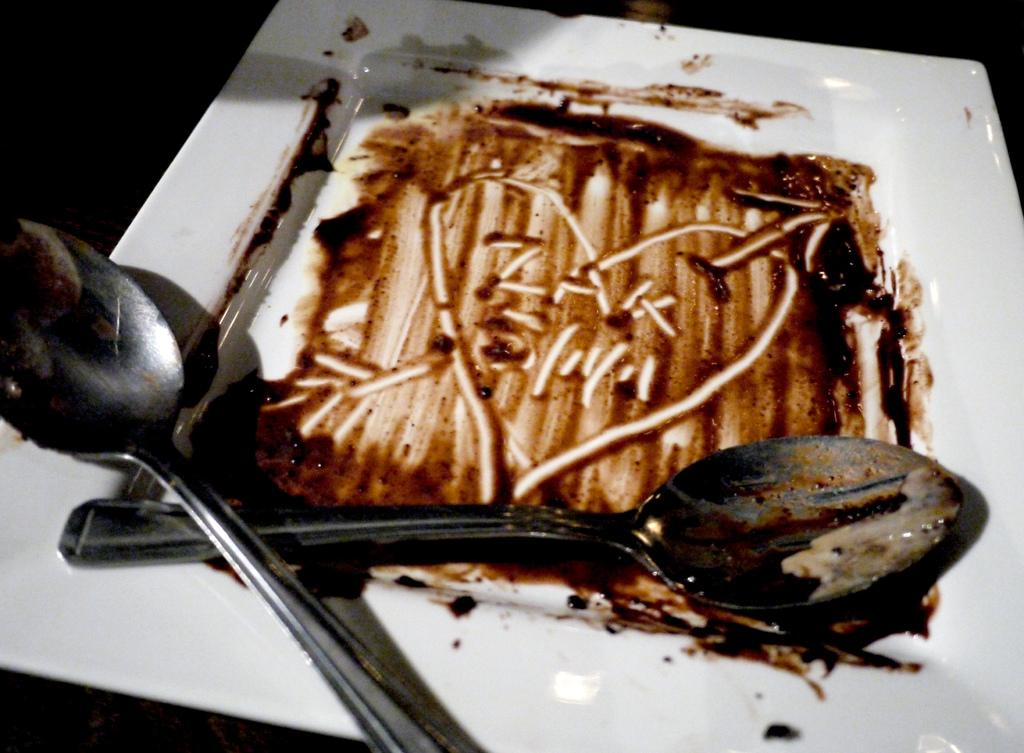What is present on the surface in the image? There is a plate in the image. Can you describe the position of the plate in the image? The plate is on a surface. How many spoons are on the plate in the image? There are two spoons on the plate. What type of wire is holding the plate in the image? There is no wire present in the image; the plate is on a surface. Where is the shelf located in the image? There is no shelf present in the image. 